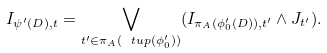<formula> <loc_0><loc_0><loc_500><loc_500>I _ { \psi ^ { \prime } ( D ) , t } = \bigvee _ { t ^ { \prime } \in \pi _ { A } ( \ t u p ( \phi ^ { \prime } _ { 0 } ) ) } ( I _ { \pi _ { A } ( \phi ^ { \prime } _ { 0 } ( D ) ) , t ^ { \prime } } \wedge J _ { t ^ { \prime } } ) .</formula> 